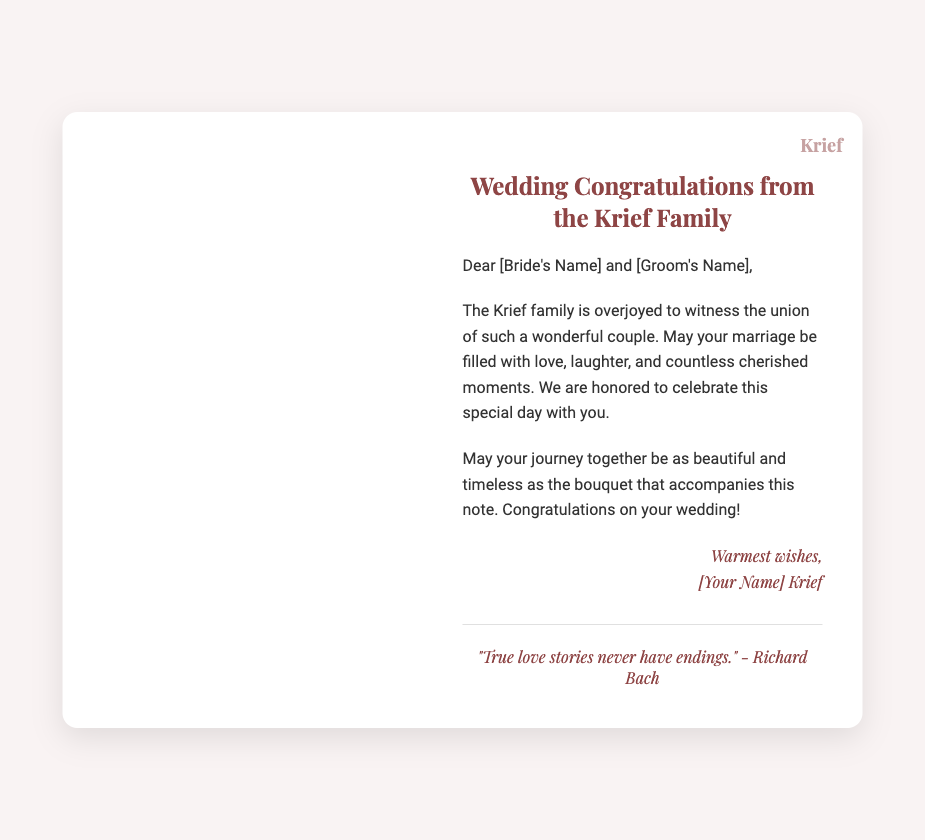What is the title of the card? The title is prominently displayed at the top of the card, indicating the purpose of the card.
Answer: Wedding Congratulations from the Krief Family Who is sending the card? The sender is mentioned in the signature at the bottom of the message, indicating their identity.
Answer: Krief Family What quote is included in the document? The quote is displayed in italics below the main text, providing a reflection on love.
Answer: "True love stories never have endings." - Richard Bach What colors are used in the card's text? The text color used for messages and titles can be identified through visual inspection.
Answer: #8e4545 and #333 What is the visual theme of the card? The overall visual elements and imagery point to a celebratory theme, particularly regarding weddings.
Answer: Flowers How is the message addressed? The document starts with a style typical of personal letters, establishing who the message is for.
Answer: Dear [Bride's Name] and [Groom's Name] What is the overall sentiment expressed in the card? The wording throughout the document reflects emotions typical of congratulatory messages.
Answer: Joy What do the Krief family wish for the couple? The document includes a specific wish for the couple related to their future together.
Answer: Love, laughter, and cherished moments 